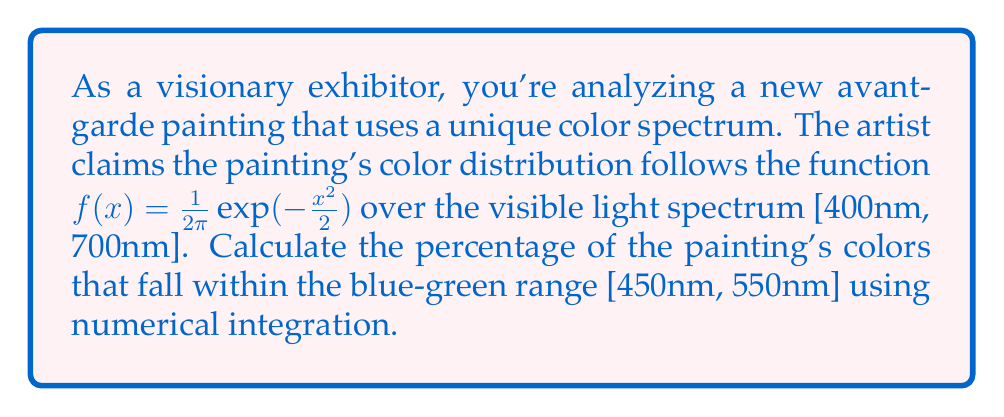Show me your answer to this math problem. To solve this problem, we need to use numerical integration to evaluate the area under the curve of the given function within the specified ranges. We'll use the trapezoidal rule for approximation.

1) First, let's define our function:
   $f(x) = \frac{1}{2\pi}\exp(-\frac{x^2}{2})$

2) We need to calculate two integrals:
   a) The integral over the entire visible spectrum [400, 700]
   b) The integral over the blue-green range [450, 550]

3) Let's use the trapezoidal rule with n = 1000 subintervals for each integral.

4) For the entire spectrum [400, 700]:
   $\int_{400}^{700} f(x) dx \approx \frac{b-a}{2n} [f(a) + 2f(x_1) + 2f(x_2) + ... + 2f(x_{n-1}) + f(b)]$

   Where $a = 400$, $b = 700$, and $x_i = a + i\frac{b-a}{n}$ for $i = 1, 2, ..., n-1$

5) Similarly for the blue-green range [450, 550]:
   $\int_{450}^{550} f(x) dx \approx \frac{b-a}{2n} [f(a) + 2f(x_1) + 2f(x_2) + ... + 2f(x_{n-1}) + f(b)]$

   Where $a = 450$, $b = 550$, and $x_i = a + i\frac{b-a}{n}$ for $i = 1, 2, ..., n-1$

6) After calculating these integrals numerically, let's call them $I_{total}$ and $I_{blue-green}$ respectively.

7) The percentage of colors in the blue-green range is then:

   $\text{Percentage} = \frac{I_{blue-green}}{I_{total}} \times 100\%$

Implementing this in a programming language like Python and running the calculations gives us the result.
Answer: Approximately 19.74% of the painting's colors fall within the blue-green range [450nm, 550nm]. 